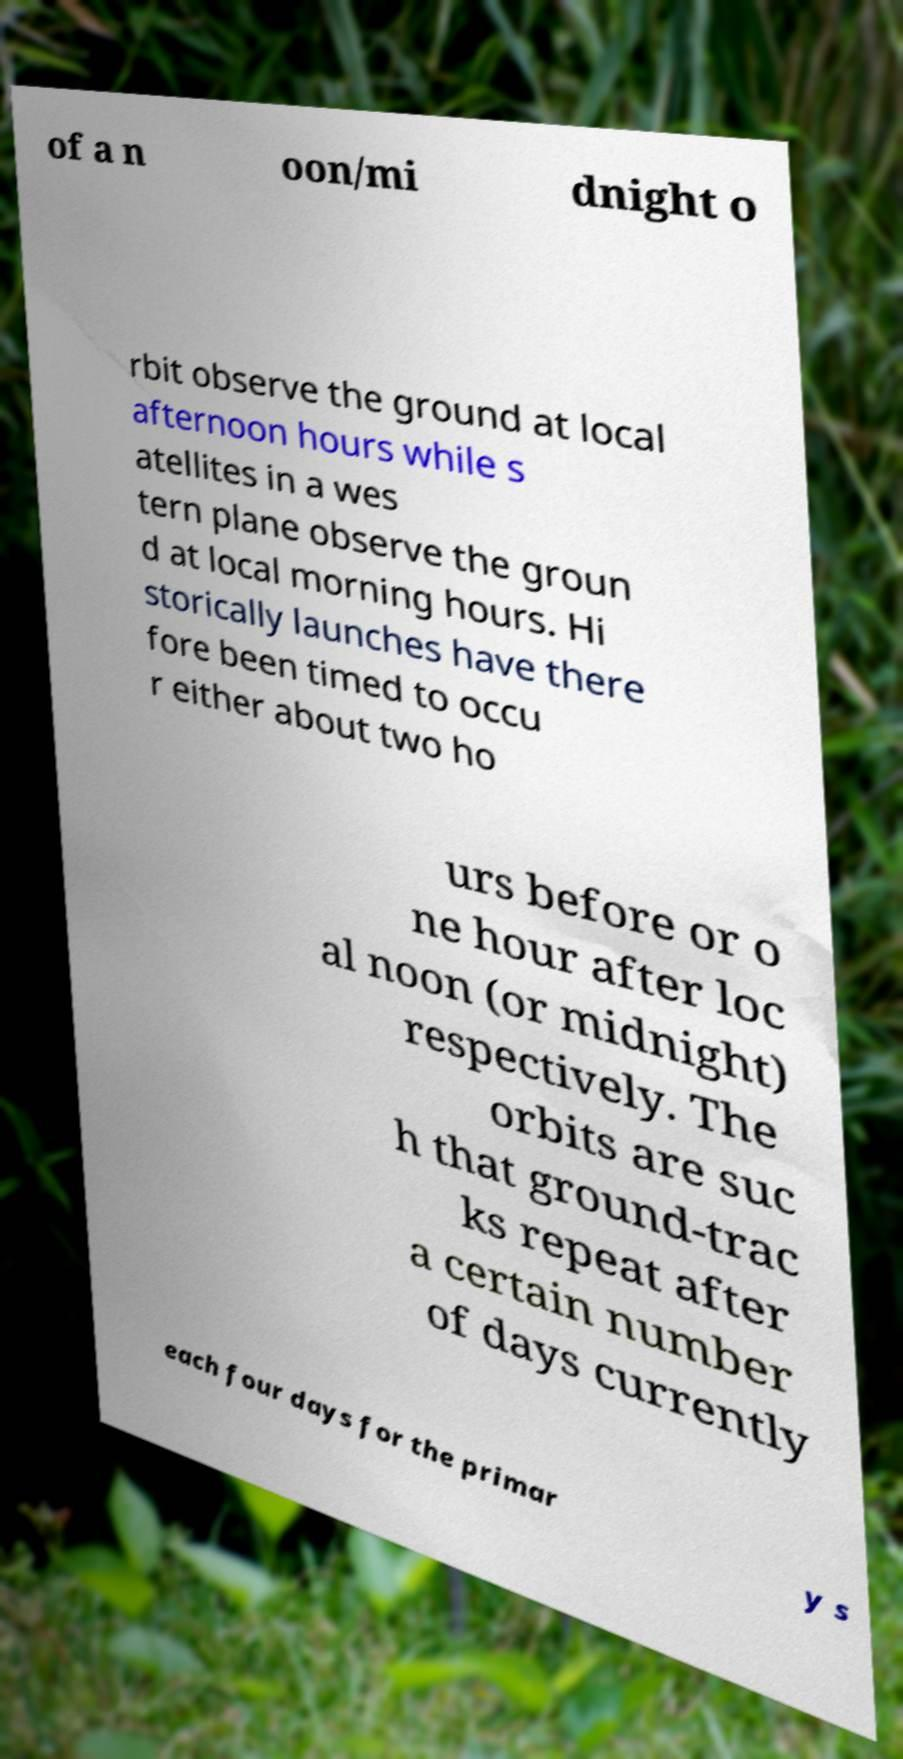Can you read and provide the text displayed in the image?This photo seems to have some interesting text. Can you extract and type it out for me? of a n oon/mi dnight o rbit observe the ground at local afternoon hours while s atellites in a wes tern plane observe the groun d at local morning hours. Hi storically launches have there fore been timed to occu r either about two ho urs before or o ne hour after loc al noon (or midnight) respectively. The orbits are suc h that ground-trac ks repeat after a certain number of days currently each four days for the primar y s 